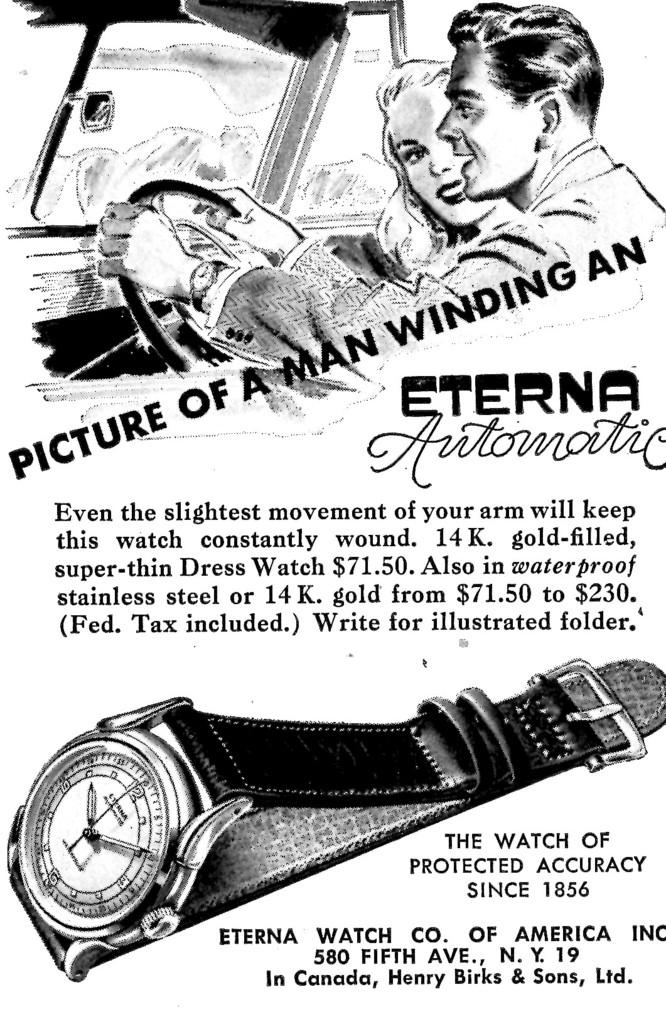<image>
Present a compact description of the photo's key features. An advertisement for the Eterna Automatc watch shows a man winding one. 